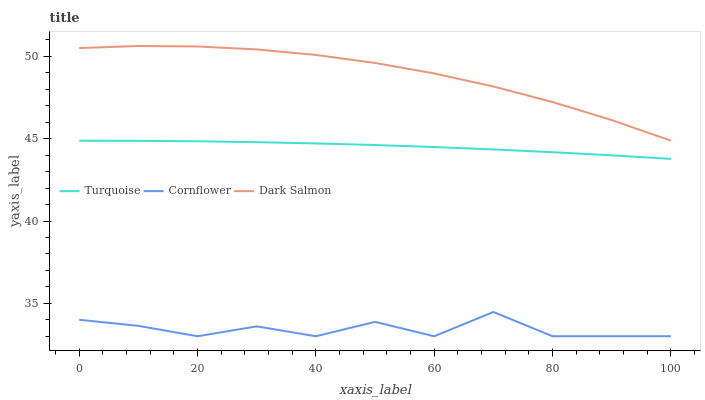Does Cornflower have the minimum area under the curve?
Answer yes or no. Yes. Does Dark Salmon have the maximum area under the curve?
Answer yes or no. Yes. Does Turquoise have the minimum area under the curve?
Answer yes or no. No. Does Turquoise have the maximum area under the curve?
Answer yes or no. No. Is Turquoise the smoothest?
Answer yes or no. Yes. Is Cornflower the roughest?
Answer yes or no. Yes. Is Dark Salmon the smoothest?
Answer yes or no. No. Is Dark Salmon the roughest?
Answer yes or no. No. Does Cornflower have the lowest value?
Answer yes or no. Yes. Does Turquoise have the lowest value?
Answer yes or no. No. Does Dark Salmon have the highest value?
Answer yes or no. Yes. Does Turquoise have the highest value?
Answer yes or no. No. Is Turquoise less than Dark Salmon?
Answer yes or no. Yes. Is Dark Salmon greater than Cornflower?
Answer yes or no. Yes. Does Turquoise intersect Dark Salmon?
Answer yes or no. No. 